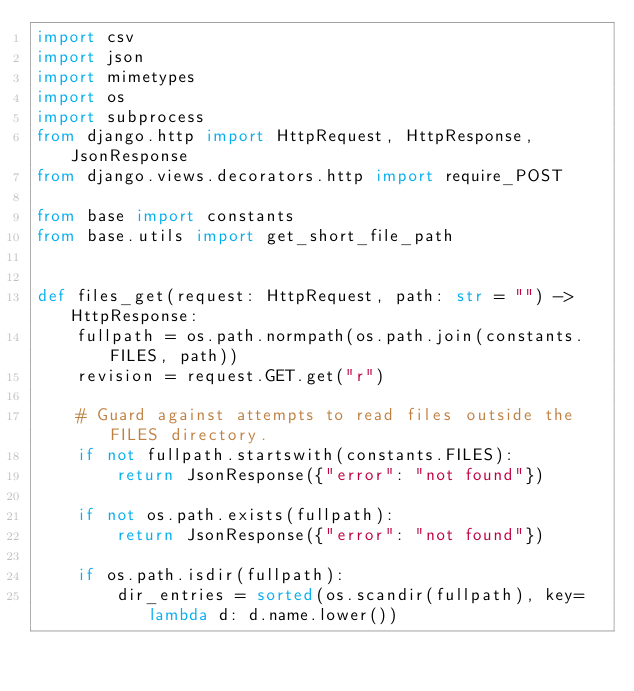Convert code to text. <code><loc_0><loc_0><loc_500><loc_500><_Python_>import csv
import json
import mimetypes
import os
import subprocess
from django.http import HttpRequest, HttpResponse, JsonResponse
from django.views.decorators.http import require_POST

from base import constants
from base.utils import get_short_file_path


def files_get(request: HttpRequest, path: str = "") -> HttpResponse:
    fullpath = os.path.normpath(os.path.join(constants.FILES, path))
    revision = request.GET.get("r")

    # Guard against attempts to read files outside the FILES directory.
    if not fullpath.startswith(constants.FILES):
        return JsonResponse({"error": "not found"})

    if not os.path.exists(fullpath):
        return JsonResponse({"error": "not found"})

    if os.path.isdir(fullpath):
        dir_entries = sorted(os.scandir(fullpath), key=lambda d: d.name.lower())</code> 